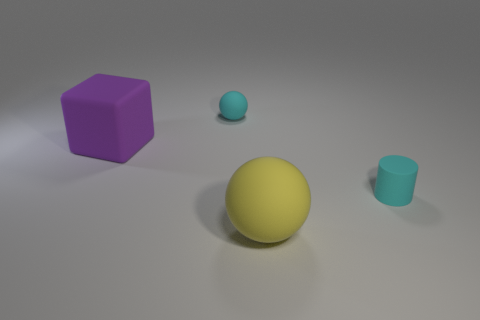What number of things are tiny rubber objects on the left side of the rubber cylinder or large rubber objects that are behind the cylinder?
Keep it short and to the point. 2. What number of other things are there of the same color as the cube?
Offer a very short reply. 0. Are there more cyan cylinders to the left of the cyan matte cylinder than purple objects that are to the right of the yellow matte thing?
Your response must be concise. No. Are there any other things that are the same size as the purple block?
Make the answer very short. Yes. How many cylinders are cyan rubber objects or small blue things?
Provide a short and direct response. 1. How many objects are tiny cyan rubber cylinders that are right of the cyan sphere or green cubes?
Make the answer very short. 1. There is a rubber object on the right side of the large rubber object to the right of the big rubber thing on the left side of the big yellow matte sphere; what is its shape?
Give a very brief answer. Cylinder. How many purple things are the same shape as the big yellow matte thing?
Provide a short and direct response. 0. What material is the small thing that is the same color as the rubber cylinder?
Offer a terse response. Rubber. Do the purple object and the yellow thing have the same material?
Keep it short and to the point. Yes. 